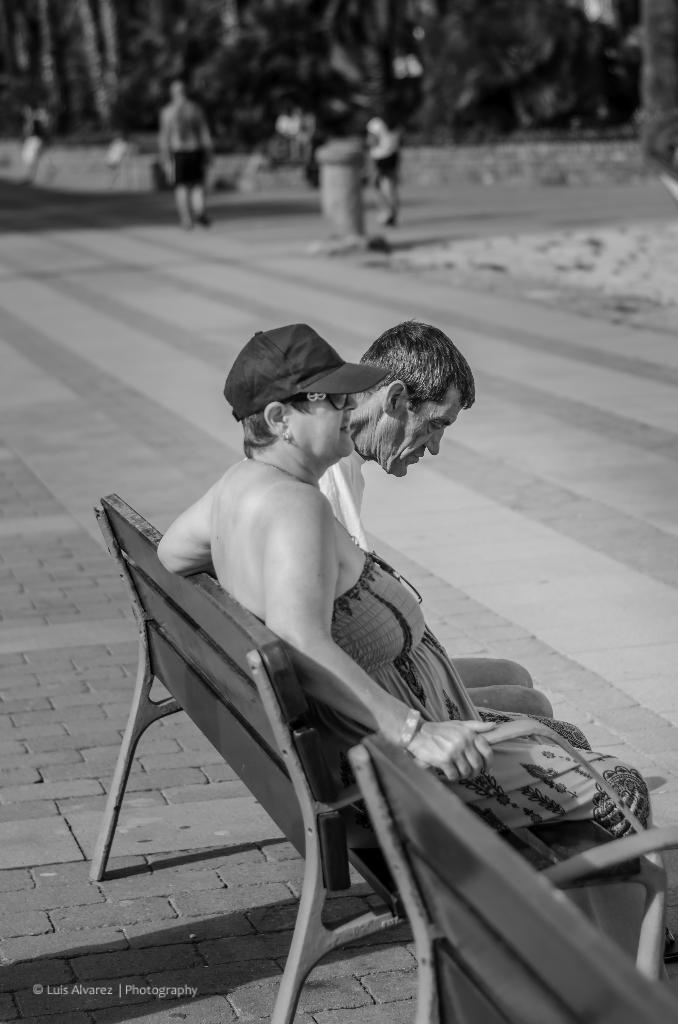How many people are sitting on the bench in the image? There are two members sitting on a bench in the image. What can be seen in the background of the image? There are people and trees in the background of the image. What is the color scheme of the image? The image is black and white. What part of the bench is causing pain to the members in the image? There is no indication of pain or any specific part of the bench causing discomfort in the image. 